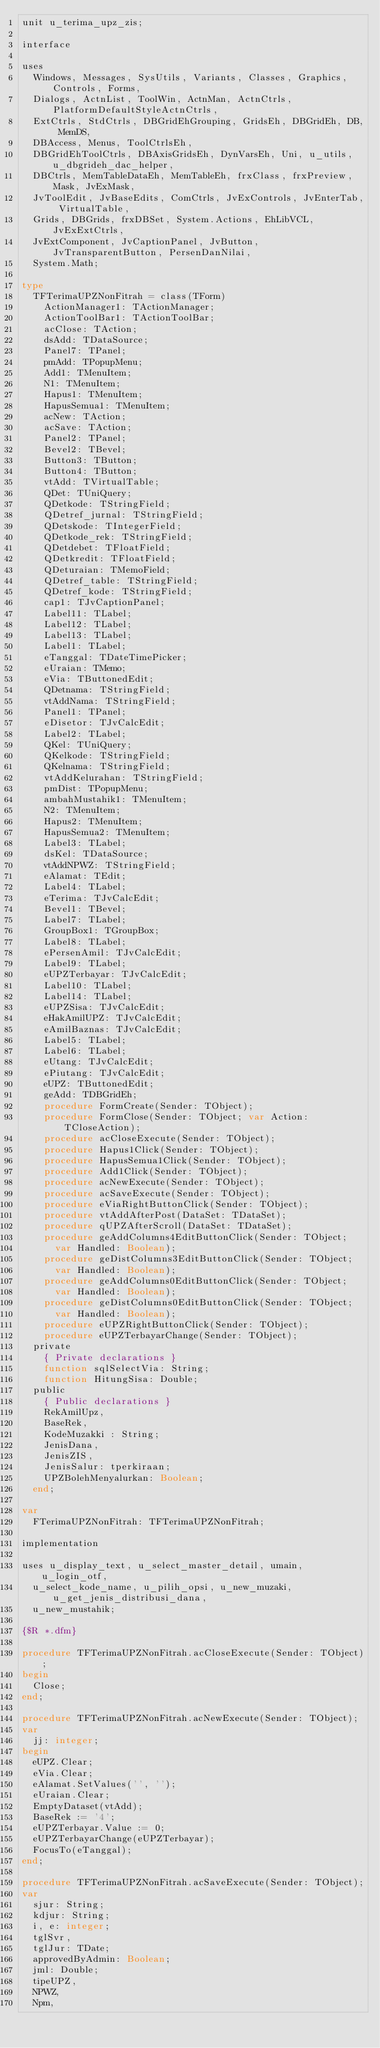Convert code to text. <code><loc_0><loc_0><loc_500><loc_500><_Pascal_>unit u_terima_upz_zis;

interface

uses
  Windows, Messages, SysUtils, Variants, Classes, Graphics, Controls, Forms,
  Dialogs, ActnList, ToolWin, ActnMan, ActnCtrls, PlatformDefaultStyleActnCtrls,
  ExtCtrls, StdCtrls, DBGridEhGrouping, GridsEh, DBGridEh, DB, MemDS,
  DBAccess, Menus, ToolCtrlsEh,
  DBGridEhToolCtrls, DBAxisGridsEh, DynVarsEh, Uni, u_utils, u_dbgrideh_dac_helper,
  DBCtrls, MemTableDataEh, MemTableEh, frxClass, frxPreview, Mask, JvExMask,
  JvToolEdit, JvBaseEdits, ComCtrls, JvExControls, JvEnterTab, VirtualTable,
  Grids, DBGrids, frxDBSet, System.Actions, EhLibVCL, JvExExtCtrls,
  JvExtComponent, JvCaptionPanel, JvButton, JvTransparentButton, PersenDanNilai,
  System.Math;

type
  TFTerimaUPZNonFitrah = class(TForm)
    ActionManager1: TActionManager;
    ActionToolBar1: TActionToolBar;
    acClose: TAction;
    dsAdd: TDataSource;
    Panel7: TPanel;
    pmAdd: TPopupMenu;
    Add1: TMenuItem;
    N1: TMenuItem;
    Hapus1: TMenuItem;
    HapusSemua1: TMenuItem;
    acNew: TAction;
    acSave: TAction;
    Panel2: TPanel;
    Bevel2: TBevel;
    Button3: TButton;
    Button4: TButton;
    vtAdd: TVirtualTable;
    QDet: TUniQuery;
    QDetkode: TStringField;
    QDetref_jurnal: TStringField;
    QDetskode: TIntegerField;
    QDetkode_rek: TStringField;
    QDetdebet: TFloatField;
    QDetkredit: TFloatField;
    QDeturaian: TMemoField;
    QDetref_table: TStringField;
    QDetref_kode: TStringField;
    cap1: TJvCaptionPanel;
    Label11: TLabel;
    Label12: TLabel;
    Label13: TLabel;
    Label1: TLabel;
    eTanggal: TDateTimePicker;
    eUraian: TMemo;
    eVia: TButtonedEdit;
    QDetnama: TStringField;
    vtAddNama: TStringField;
    Panel1: TPanel;
    eDisetor: TJvCalcEdit;
    Label2: TLabel;
    QKel: TUniQuery;
    QKelkode: TStringField;
    QKelnama: TStringField;
    vtAddKelurahan: TStringField;
    pmDist: TPopupMenu;
    ambahMustahik1: TMenuItem;
    N2: TMenuItem;
    Hapus2: TMenuItem;
    HapusSemua2: TMenuItem;
    Label3: TLabel;
    dsKel: TDataSource;
    vtAddNPWZ: TStringField;
    eAlamat: TEdit;
    Label4: TLabel;
    eTerima: TJvCalcEdit;
    Bevel1: TBevel;
    Label7: TLabel;
    GroupBox1: TGroupBox;
    Label8: TLabel;
    ePersenAmil: TJvCalcEdit;
    Label9: TLabel;
    eUPZTerbayar: TJvCalcEdit;
    Label10: TLabel;
    Label14: TLabel;
    eUPZSisa: TJvCalcEdit;
    eHakAmilUPZ: TJvCalcEdit;
    eAmilBaznas: TJvCalcEdit;
    Label5: TLabel;
    Label6: TLabel;
    eUtang: TJvCalcEdit;
    ePiutang: TJvCalcEdit;
    eUPZ: TButtonedEdit;
    geAdd: TDBGridEh;
    procedure FormCreate(Sender: TObject);
    procedure FormClose(Sender: TObject; var Action: TCloseAction);
    procedure acCloseExecute(Sender: TObject);
    procedure Hapus1Click(Sender: TObject);
    procedure HapusSemua1Click(Sender: TObject);
    procedure Add1Click(Sender: TObject);
    procedure acNewExecute(Sender: TObject);
    procedure acSaveExecute(Sender: TObject);
    procedure eViaRightButtonClick(Sender: TObject);
    procedure vtAddAfterPost(DataSet: TDataSet);
    procedure qUPZAfterScroll(DataSet: TDataSet);
    procedure geAddColumns4EditButtonClick(Sender: TObject;
      var Handled: Boolean);
    procedure geDistColumns3EditButtonClick(Sender: TObject;
      var Handled: Boolean);
    procedure geAddColumns0EditButtonClick(Sender: TObject;
      var Handled: Boolean);
    procedure geDistColumns0EditButtonClick(Sender: TObject;
      var Handled: Boolean);
    procedure eUPZRightButtonClick(Sender: TObject);
    procedure eUPZTerbayarChange(Sender: TObject);
  private
    { Private declarations }
    function sqlSelectVia: String;
    function HitungSisa: Double;
  public
    { Public declarations }
    RekAmilUpz,
    BaseRek,
    KodeMuzakki : String;
    JenisDana,
    JenisZIS,
    JenisSalur: tperkiraan;
    UPZBolehMenyalurkan: Boolean;
  end;

var
  FTerimaUPZNonFitrah: TFTerimaUPZNonFitrah;

implementation

uses u_display_text, u_select_master_detail, umain, u_login_otf,
  u_select_kode_name, u_pilih_opsi, u_new_muzaki, u_get_jenis_distribusi_dana,
  u_new_mustahik;

{$R *.dfm}

procedure TFTerimaUPZNonFitrah.acCloseExecute(Sender: TObject);
begin
  Close;
end;

procedure TFTerimaUPZNonFitrah.acNewExecute(Sender: TObject);
var
  jj: integer;
begin
  eUPZ.Clear;
  eVia.Clear;
  eAlamat.SetValues('', '');
  eUraian.Clear;
  EmptyDataset(vtAdd);
  BaseRek := '4';
  eUPZTerbayar.Value := 0;
  eUPZTerbayarChange(eUPZTerbayar);
  FocusTo(eTanggal);
end;

procedure TFTerimaUPZNonFitrah.acSaveExecute(Sender: TObject);
var
  sjur: String;
  kdjur: String;
  i, e: integer;
  tglSvr,
  tglJur: TDate;
  approvedByAdmin: Boolean;
  jml: Double;
  tipeUPZ,
  NPWZ,
  Npm,</code> 